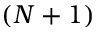<formula> <loc_0><loc_0><loc_500><loc_500>( N + 1 )</formula> 